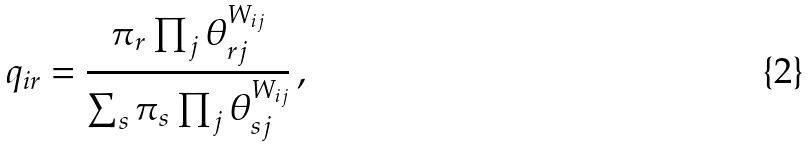Convert formula to latex. <formula><loc_0><loc_0><loc_500><loc_500>q _ { i r } = \frac { \pi _ { r } \prod _ { j } { \theta _ { r j } ^ { W _ { i j } } } } { \sum _ { s } { \pi _ { s } \prod _ { j } { \theta _ { s j } ^ { W _ { i j } } } } } \, ,</formula> 